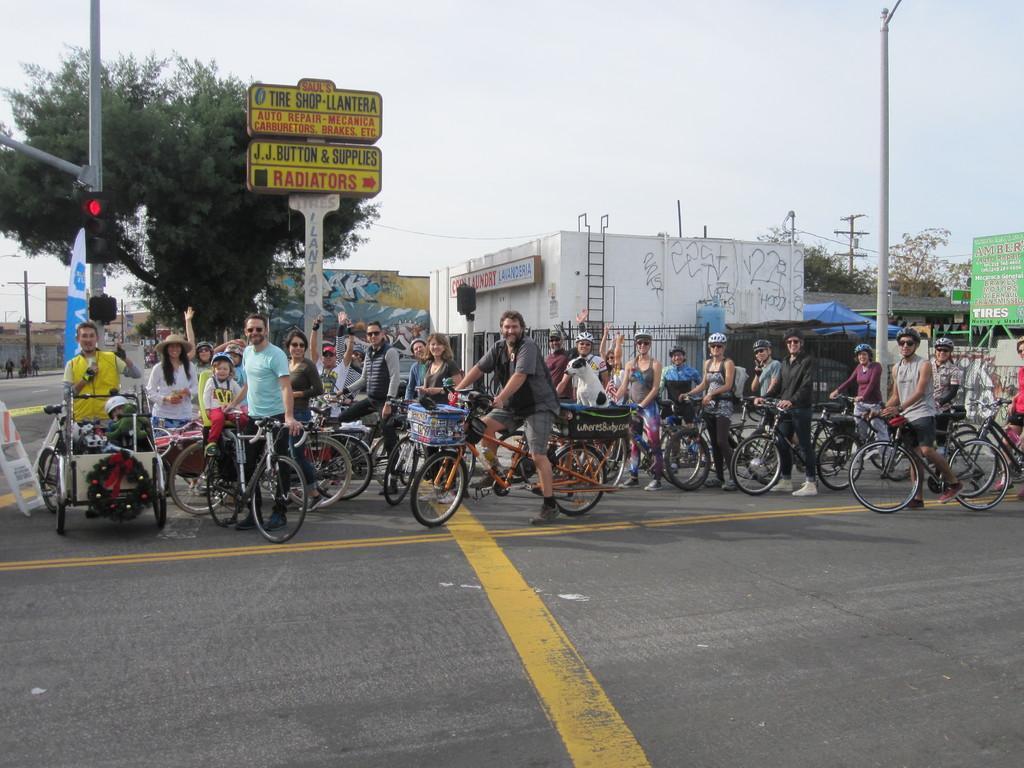In one or two sentences, can you explain what this image depicts? In this image we can see a group of people on the road holding the bicycles. We can also see a wreath with a ribbon on a vehicle, the traffic light, a sign board , a board with some text on it, some buildings, a ladder, some utility poles with wires and the sky which looks cloudy. 